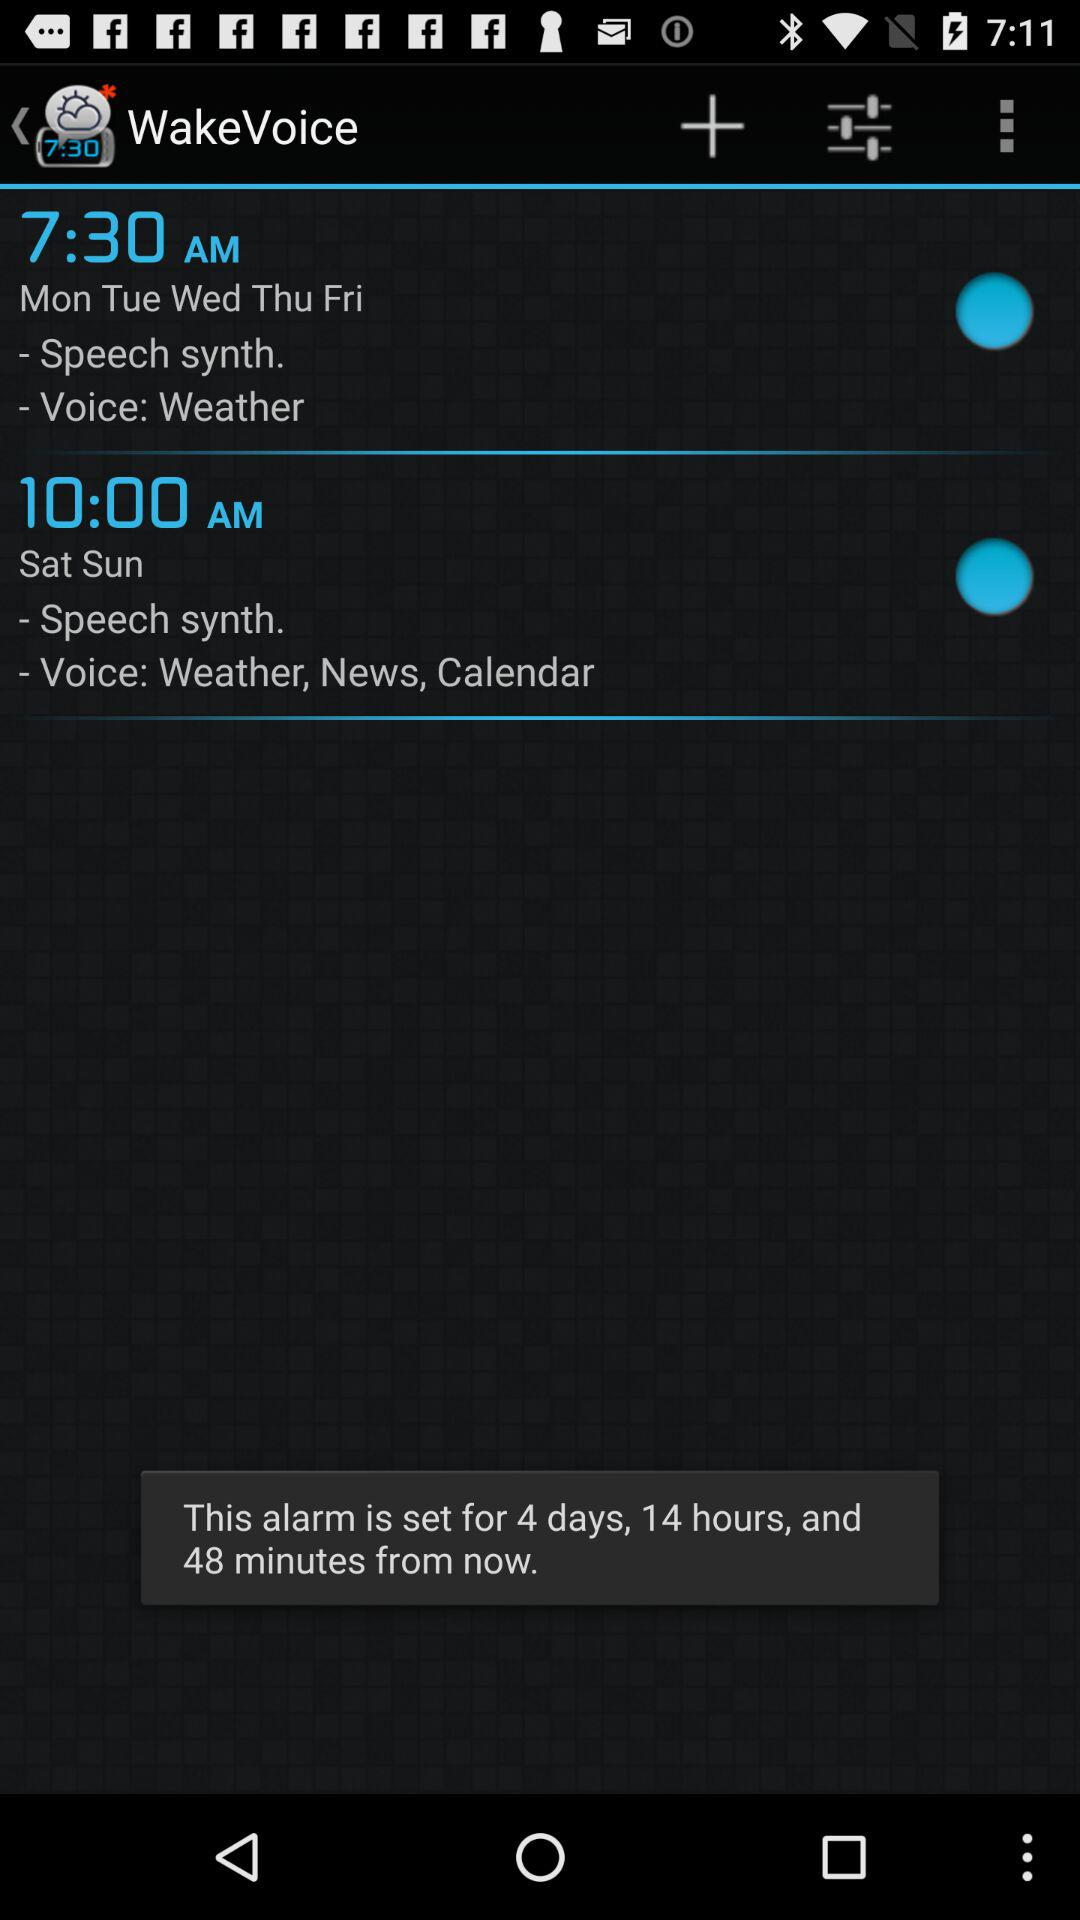What is the wake-up time on weekdays? The wake-up time on weekdays is 7:30 a.m. 